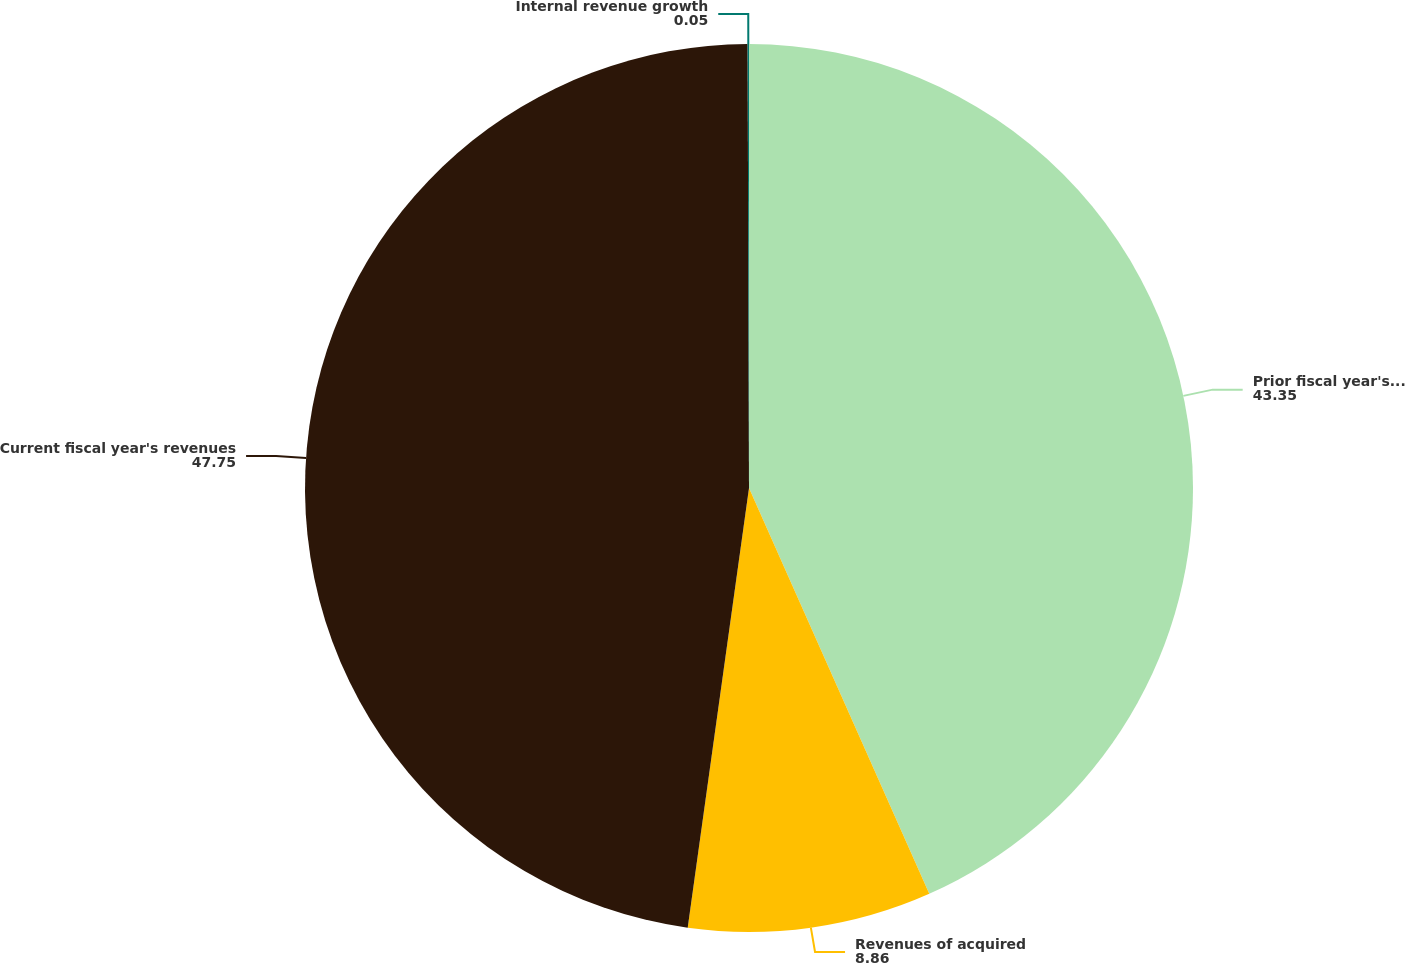Convert chart to OTSL. <chart><loc_0><loc_0><loc_500><loc_500><pie_chart><fcel>Prior fiscal year's revenues<fcel>Revenues of acquired<fcel>Current fiscal year's revenues<fcel>Internal revenue growth<nl><fcel>43.35%<fcel>8.86%<fcel>47.75%<fcel>0.05%<nl></chart> 